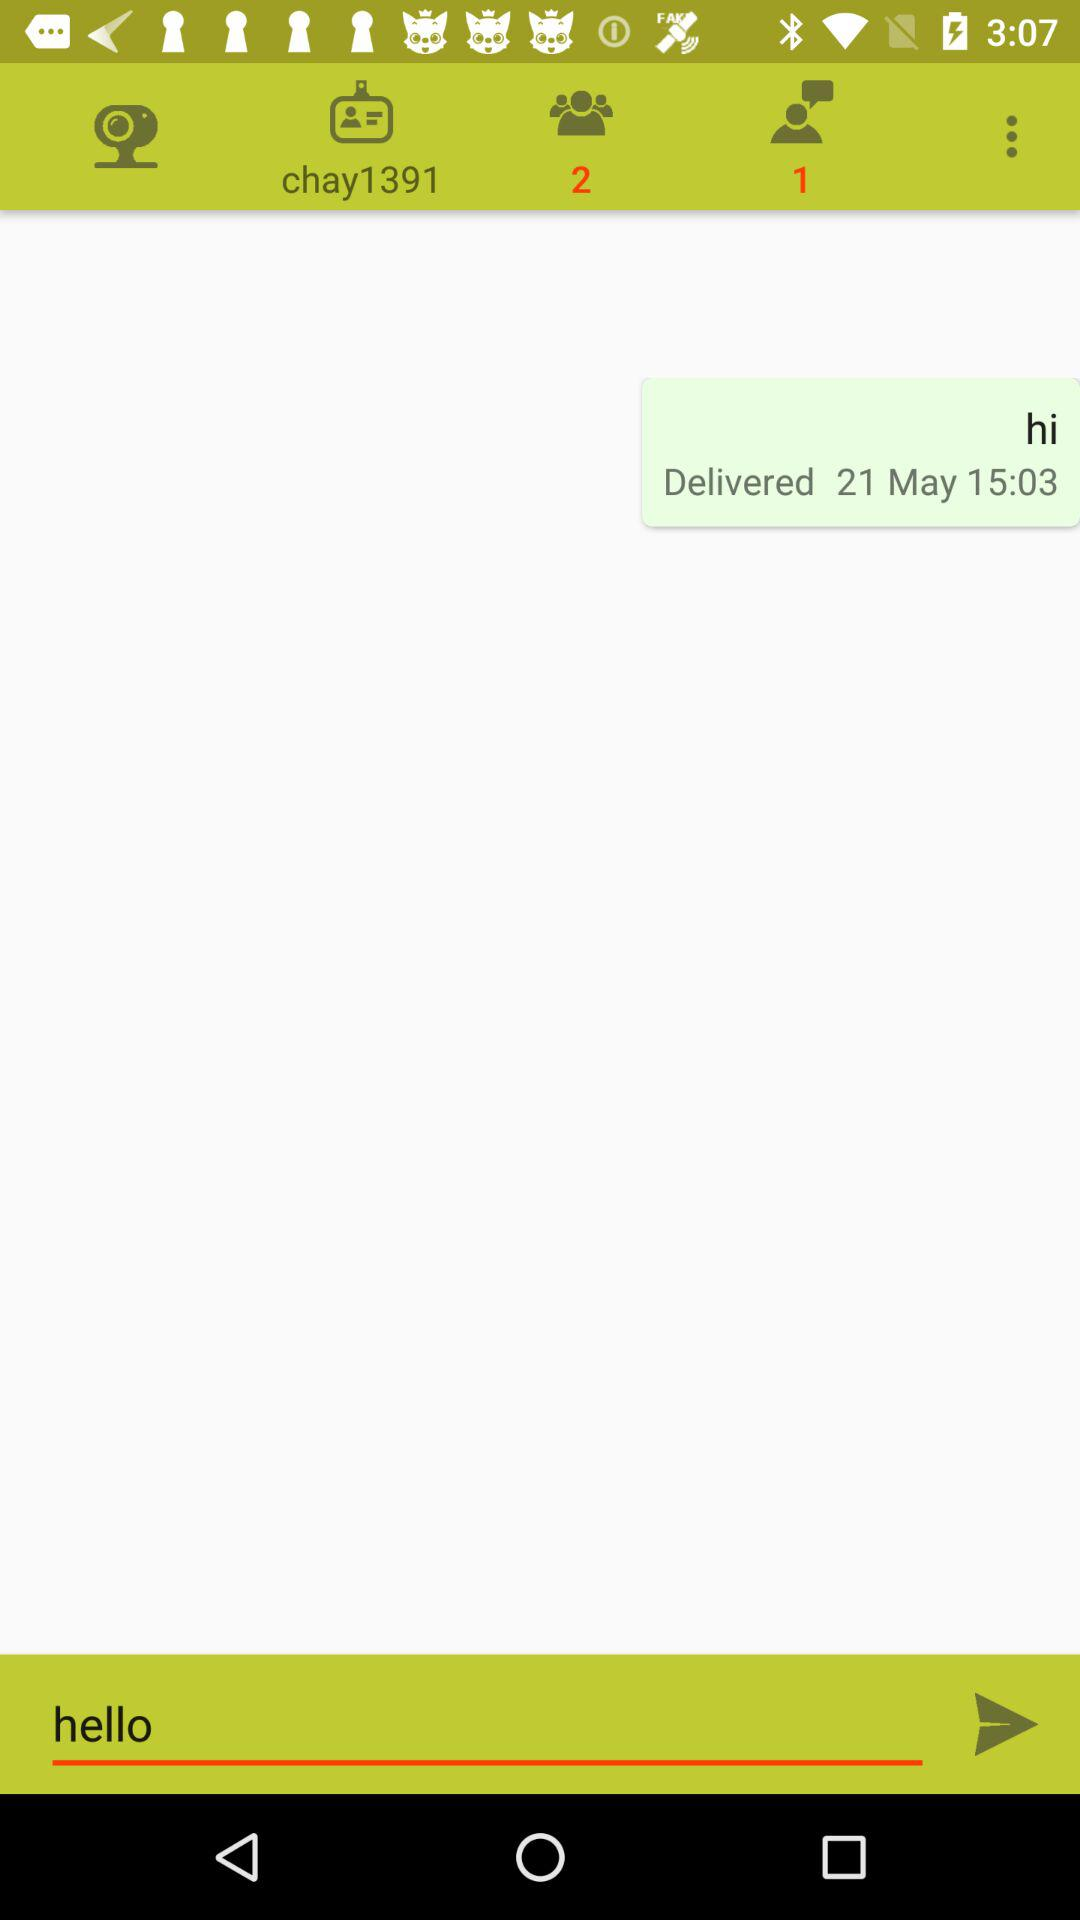What type of app is shown in the image? The image displays a messaging app interface, characterized by the text input field at the bottom, the speech bubble with a timestamp, and notification icons indicative of messaging activity. 